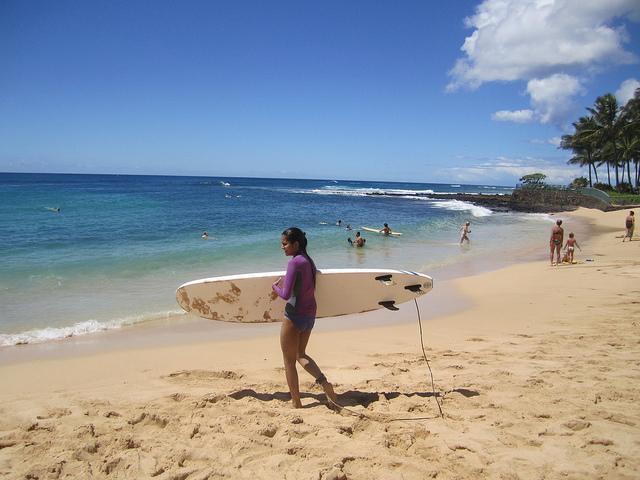How many people are carrying surfboards?
Give a very brief answer. 1. How many surfboards?
Give a very brief answer. 2. How many jet skis do you see?
Give a very brief answer. 0. 